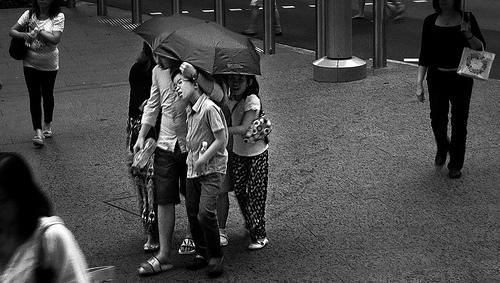Question: why are they holding an umbrella?
Choices:
A. It's sunny.
B. It's hailing.
C. It's pouring.
D. Raining.
Answer with the letter. Answer: D Question: what is over the groups heads?
Choices:
A. Shade.
B. The Sky.
C. Trees.
D. Umbrella.
Answer with the letter. Answer: D Question: how many people are under the umbrella together?
Choices:
A. 12.
B. 5.
C. 13.
D. 10.
Answer with the letter. Answer: B Question: what color is the umbrella?
Choices:
A. Teal.
B. Black.
C. Purple.
D. Neon.
Answer with the letter. Answer: B 